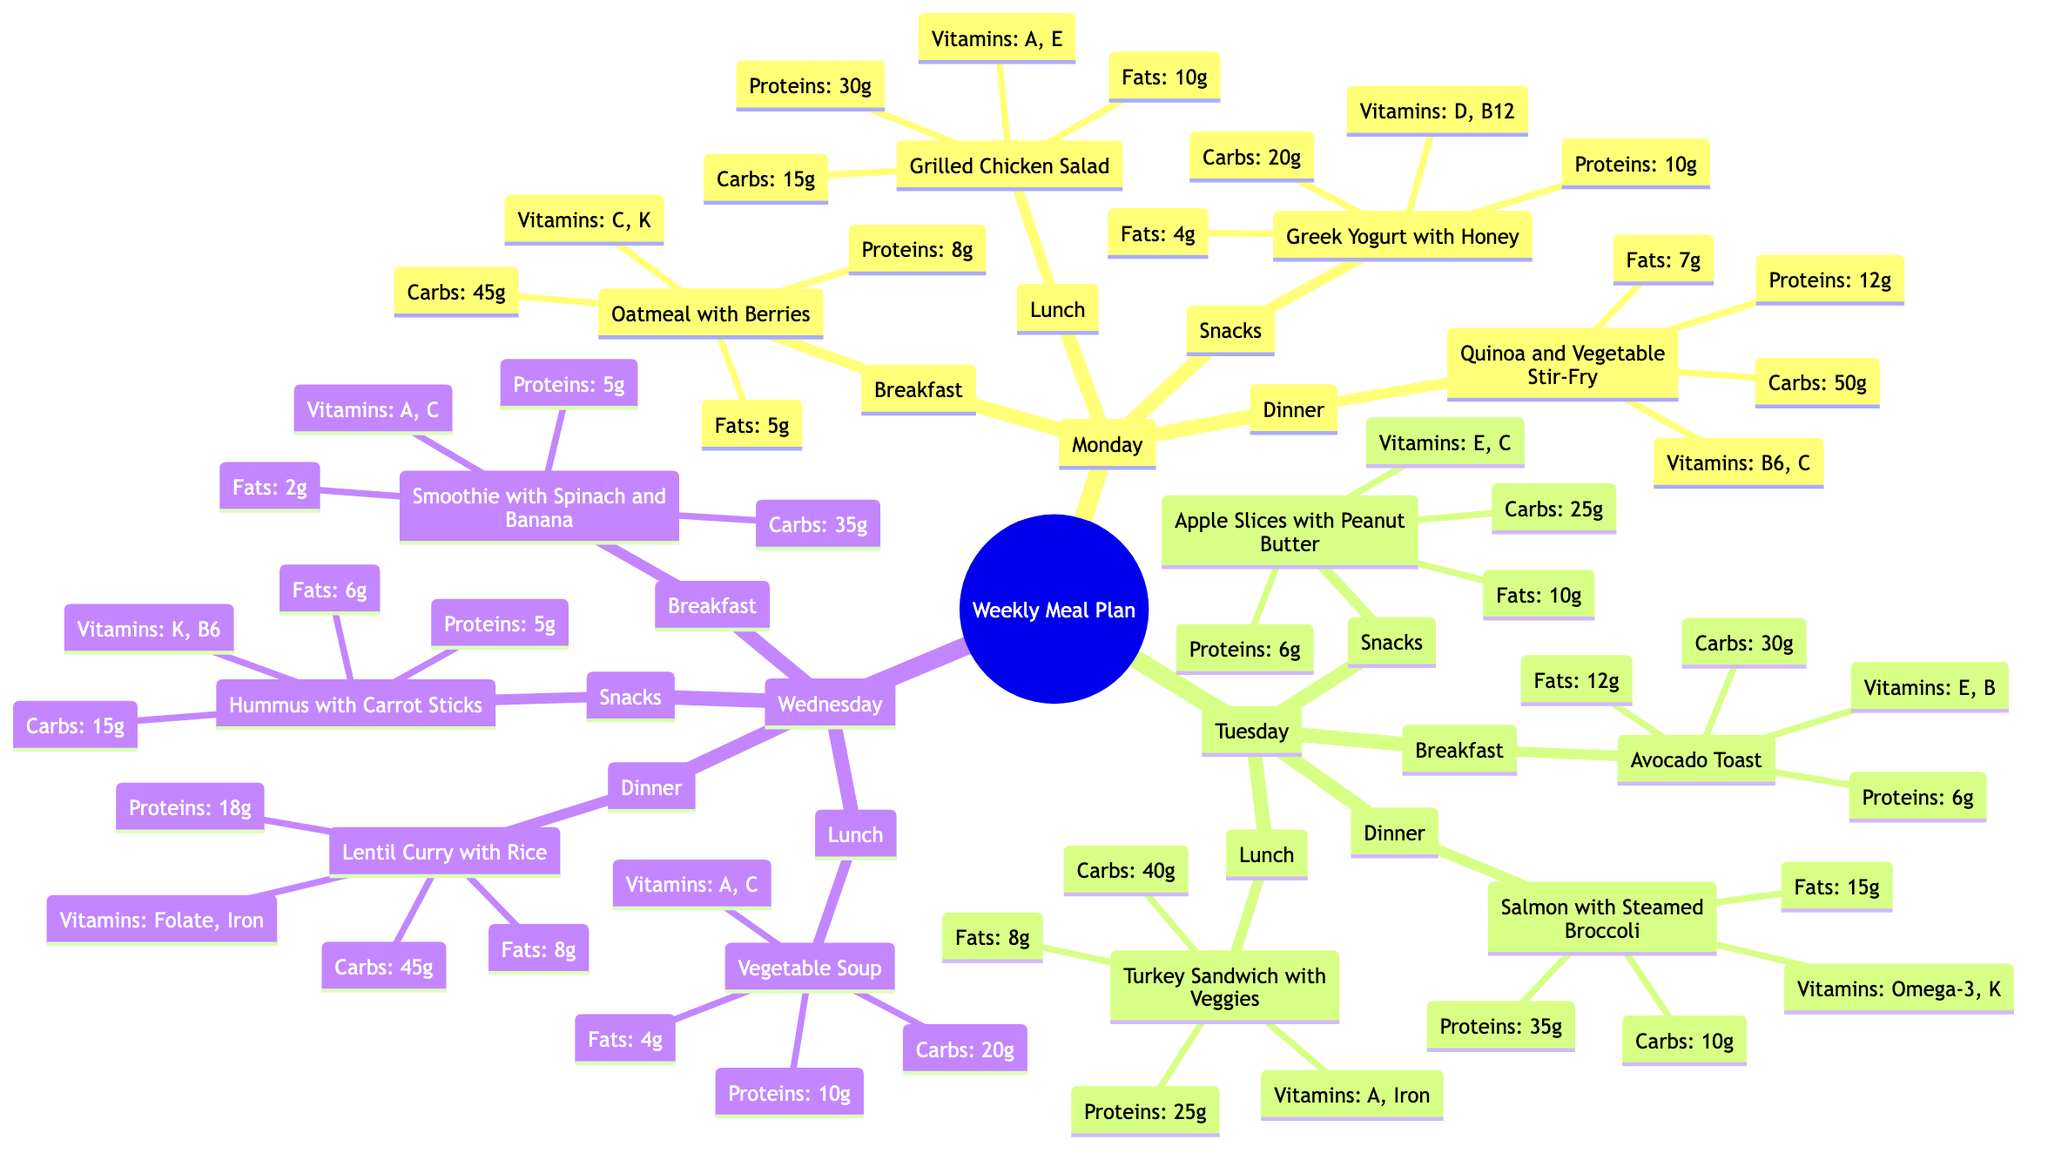What is the total carbohydrate amount in Monday's dinner? For Monday's dinner, the carbohydrate content of Quinoa and Vegetable Stir-Fry is given as 50g. Therefore, the total carbohydrate amount is directly taken from this meal.
Answer: 50g What vitamins are present in Tuesday's lunch? In Tuesday's lunch, the Turkey Sandwich with Veggies is provided, and the vitamins listed for this meal are A and Iron. The answer combines both vitamins mentioned.
Answer: A, Iron Which meal has the highest protein content on Wednesday? On Wednesday, the meals listed include Smoothie with Spinach and Banana (5g), Vegetable Soup (10g), Lentil Curry with Rice (18g), and Hummus with Carrot Sticks (5g). Among these, the Lentil Curry with Rice contains the highest protein content, which is 18g.
Answer: 18g What type of dish is served for breakfast on Monday? The breakfast listed for Monday is Oatmeal with Berries. By directly referencing the node in the diagram, we identify the type of dish.
Answer: Oatmeal with Berries How many snacks are listed for Wednesday? There are snacks listed for Wednesday, specifically Hummus with Carrot Sticks. The meal plan provides only one snack option for that day. Therefore, the answer reflects the count of snack options available for Wednesday.
Answer: 1 